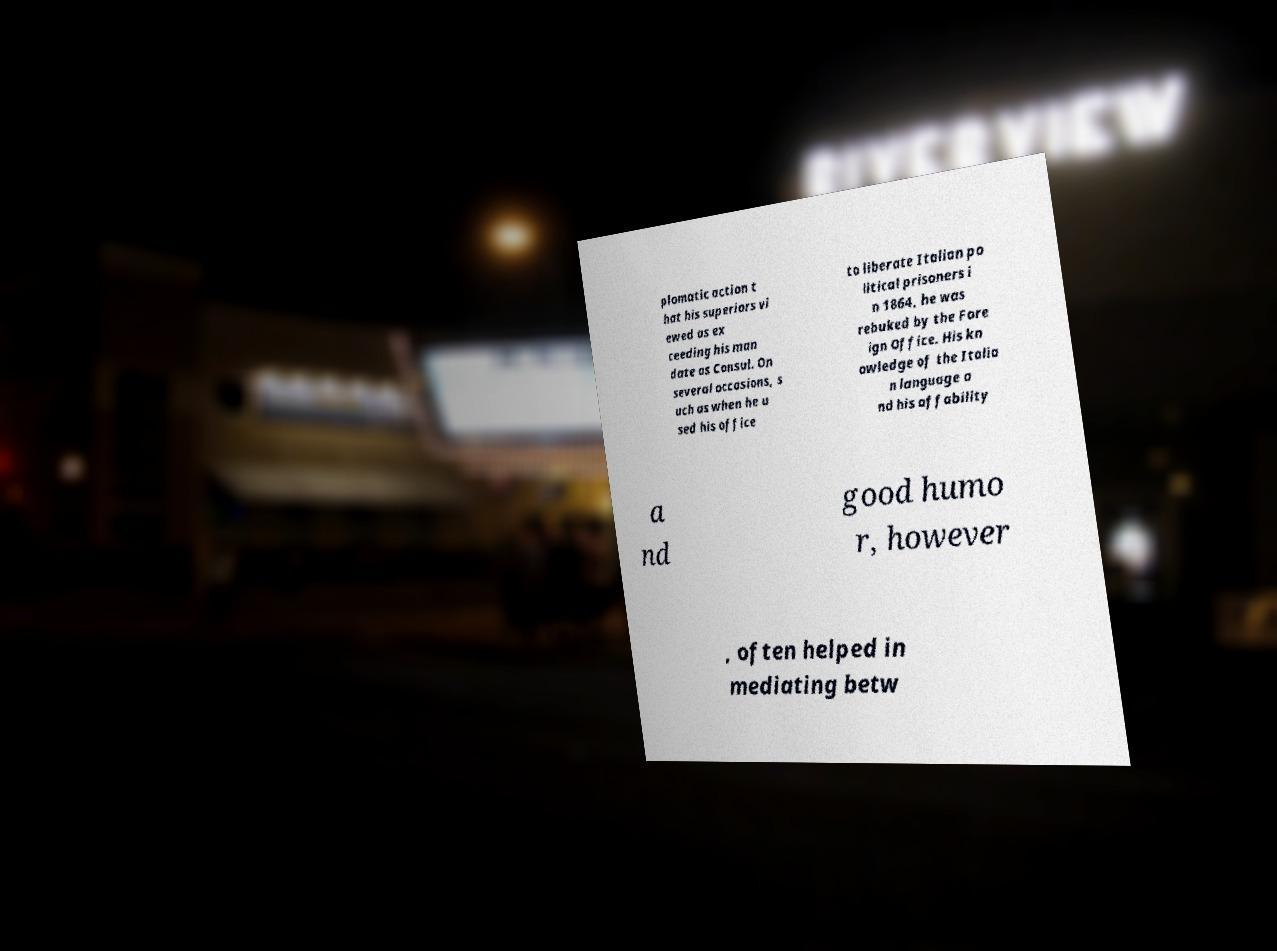There's text embedded in this image that I need extracted. Can you transcribe it verbatim? plomatic action t hat his superiors vi ewed as ex ceeding his man date as Consul. On several occasions, s uch as when he u sed his office to liberate Italian po litical prisoners i n 1864, he was rebuked by the Fore ign Office. His kn owledge of the Italia n language a nd his affability a nd good humo r, however , often helped in mediating betw 